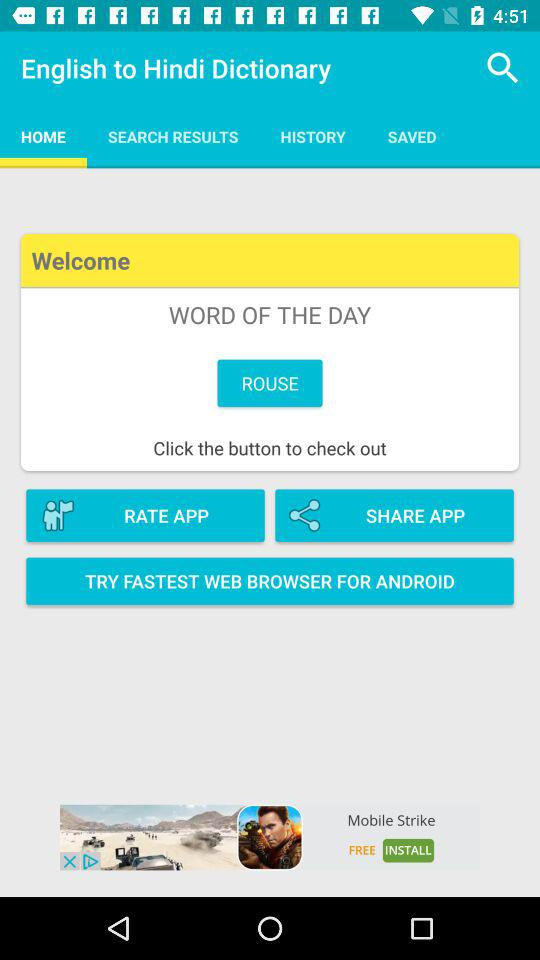What's the word of the day? The word of the day is "ROUSE". 